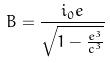Convert formula to latex. <formula><loc_0><loc_0><loc_500><loc_500>B = \frac { i _ { 0 } e } { \sqrt { 1 - \frac { e ^ { 3 } } { c ^ { 3 } } } }</formula> 